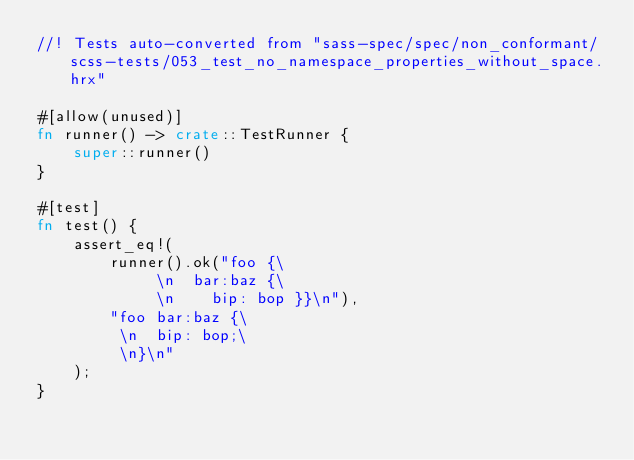Convert code to text. <code><loc_0><loc_0><loc_500><loc_500><_Rust_>//! Tests auto-converted from "sass-spec/spec/non_conformant/scss-tests/053_test_no_namespace_properties_without_space.hrx"

#[allow(unused)]
fn runner() -> crate::TestRunner {
    super::runner()
}

#[test]
fn test() {
    assert_eq!(
        runner().ok("foo {\
             \n  bar:baz {\
             \n    bip: bop }}\n"),
        "foo bar:baz {\
         \n  bip: bop;\
         \n}\n"
    );
}
</code> 